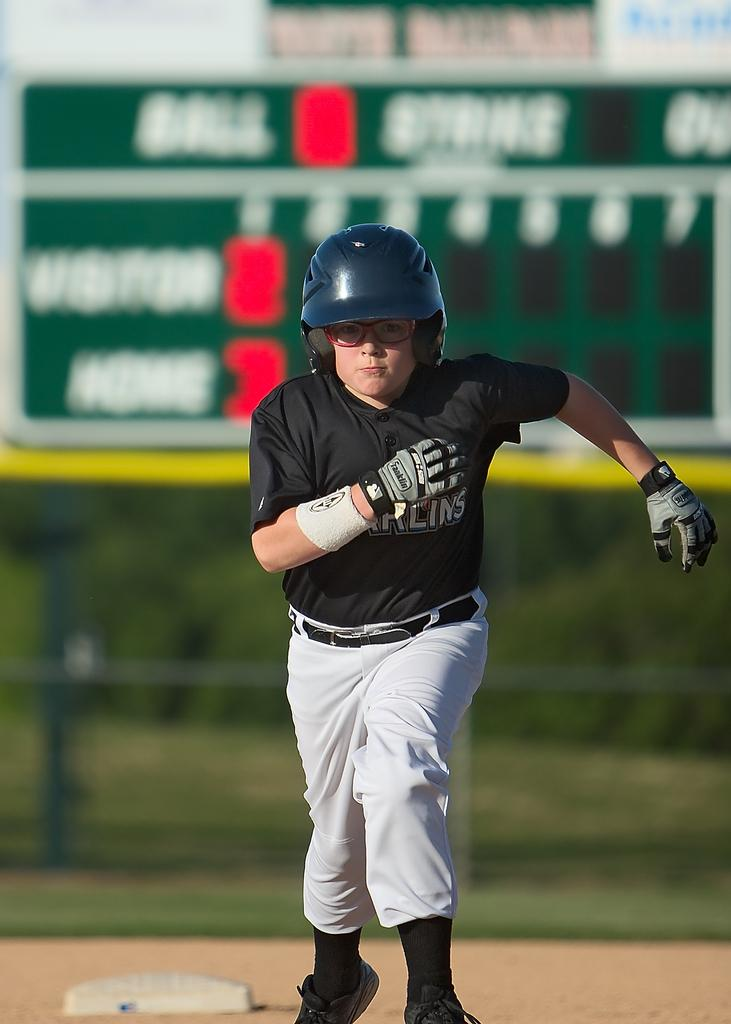<image>
Create a compact narrative representing the image presented. A young man with glasses runs the bases wearing a batting helmet and Franklin gloves. 